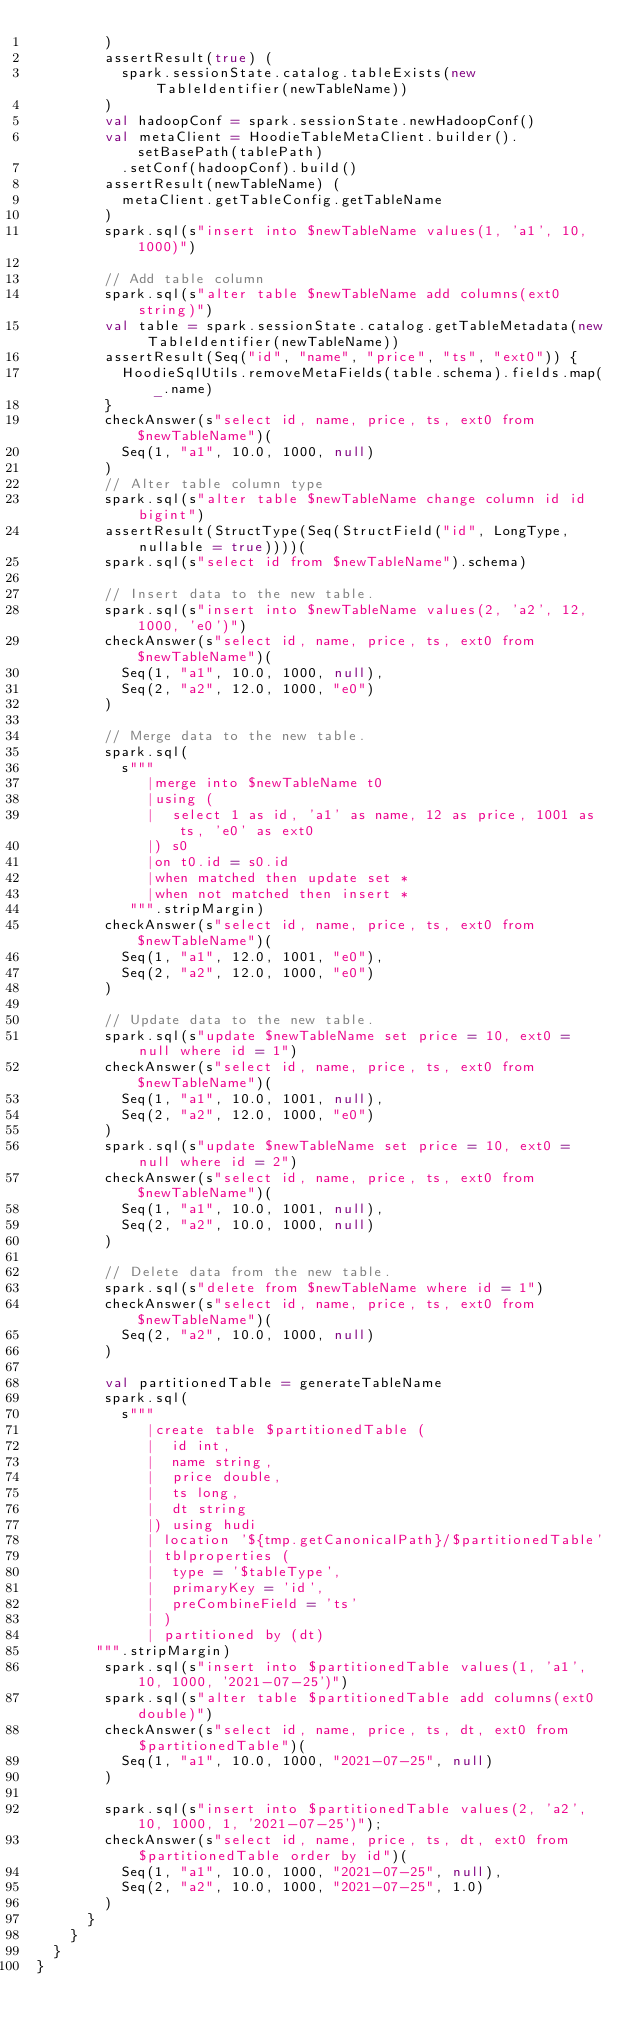<code> <loc_0><loc_0><loc_500><loc_500><_Scala_>        )
        assertResult(true) (
          spark.sessionState.catalog.tableExists(new TableIdentifier(newTableName))
        )
        val hadoopConf = spark.sessionState.newHadoopConf()
        val metaClient = HoodieTableMetaClient.builder().setBasePath(tablePath)
          .setConf(hadoopConf).build()
        assertResult(newTableName) (
          metaClient.getTableConfig.getTableName
        )
        spark.sql(s"insert into $newTableName values(1, 'a1', 10, 1000)")

        // Add table column
        spark.sql(s"alter table $newTableName add columns(ext0 string)")
        val table = spark.sessionState.catalog.getTableMetadata(new TableIdentifier(newTableName))
        assertResult(Seq("id", "name", "price", "ts", "ext0")) {
          HoodieSqlUtils.removeMetaFields(table.schema).fields.map(_.name)
        }
        checkAnswer(s"select id, name, price, ts, ext0 from $newTableName")(
          Seq(1, "a1", 10.0, 1000, null)
        )
        // Alter table column type
        spark.sql(s"alter table $newTableName change column id id bigint")
        assertResult(StructType(Seq(StructField("id", LongType, nullable = true))))(
        spark.sql(s"select id from $newTableName").schema)

        // Insert data to the new table.
        spark.sql(s"insert into $newTableName values(2, 'a2', 12, 1000, 'e0')")
        checkAnswer(s"select id, name, price, ts, ext0 from $newTableName")(
          Seq(1, "a1", 10.0, 1000, null),
          Seq(2, "a2", 12.0, 1000, "e0")
        )

        // Merge data to the new table.
        spark.sql(
          s"""
             |merge into $newTableName t0
             |using (
             |  select 1 as id, 'a1' as name, 12 as price, 1001 as ts, 'e0' as ext0
             |) s0
             |on t0.id = s0.id
             |when matched then update set *
             |when not matched then insert *
           """.stripMargin)
        checkAnswer(s"select id, name, price, ts, ext0 from $newTableName")(
          Seq(1, "a1", 12.0, 1001, "e0"),
          Seq(2, "a2", 12.0, 1000, "e0")
        )

        // Update data to the new table.
        spark.sql(s"update $newTableName set price = 10, ext0 = null where id = 1")
        checkAnswer(s"select id, name, price, ts, ext0 from $newTableName")(
          Seq(1, "a1", 10.0, 1001, null),
          Seq(2, "a2", 12.0, 1000, "e0")
        )
        spark.sql(s"update $newTableName set price = 10, ext0 = null where id = 2")
        checkAnswer(s"select id, name, price, ts, ext0 from $newTableName")(
          Seq(1, "a1", 10.0, 1001, null),
          Seq(2, "a2", 10.0, 1000, null)
        )

        // Delete data from the new table.
        spark.sql(s"delete from $newTableName where id = 1")
        checkAnswer(s"select id, name, price, ts, ext0 from $newTableName")(
          Seq(2, "a2", 10.0, 1000, null)
        )

        val partitionedTable = generateTableName
        spark.sql(
          s"""
             |create table $partitionedTable (
             |  id int,
             |  name string,
             |  price double,
             |  ts long,
             |  dt string
             |) using hudi
             | location '${tmp.getCanonicalPath}/$partitionedTable'
             | tblproperties (
             |  type = '$tableType',
             |  primaryKey = 'id',
             |  preCombineField = 'ts'
             | )
             | partitioned by (dt)
       """.stripMargin)
        spark.sql(s"insert into $partitionedTable values(1, 'a1', 10, 1000, '2021-07-25')")
        spark.sql(s"alter table $partitionedTable add columns(ext0 double)")
        checkAnswer(s"select id, name, price, ts, dt, ext0 from $partitionedTable")(
          Seq(1, "a1", 10.0, 1000, "2021-07-25", null)
        )

        spark.sql(s"insert into $partitionedTable values(2, 'a2', 10, 1000, 1, '2021-07-25')");
        checkAnswer(s"select id, name, price, ts, dt, ext0 from $partitionedTable order by id")(
          Seq(1, "a1", 10.0, 1000, "2021-07-25", null),
          Seq(2, "a2", 10.0, 1000, "2021-07-25", 1.0)
        )
      }
    }
  }
}
</code> 